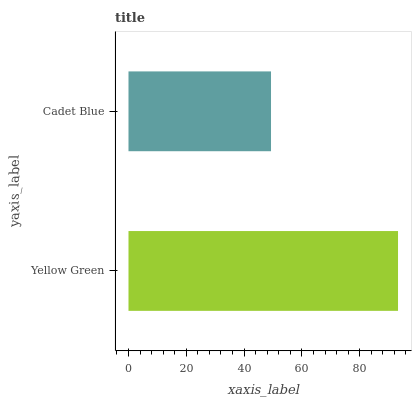Is Cadet Blue the minimum?
Answer yes or no. Yes. Is Yellow Green the maximum?
Answer yes or no. Yes. Is Cadet Blue the maximum?
Answer yes or no. No. Is Yellow Green greater than Cadet Blue?
Answer yes or no. Yes. Is Cadet Blue less than Yellow Green?
Answer yes or no. Yes. Is Cadet Blue greater than Yellow Green?
Answer yes or no. No. Is Yellow Green less than Cadet Blue?
Answer yes or no. No. Is Yellow Green the high median?
Answer yes or no. Yes. Is Cadet Blue the low median?
Answer yes or no. Yes. Is Cadet Blue the high median?
Answer yes or no. No. Is Yellow Green the low median?
Answer yes or no. No. 